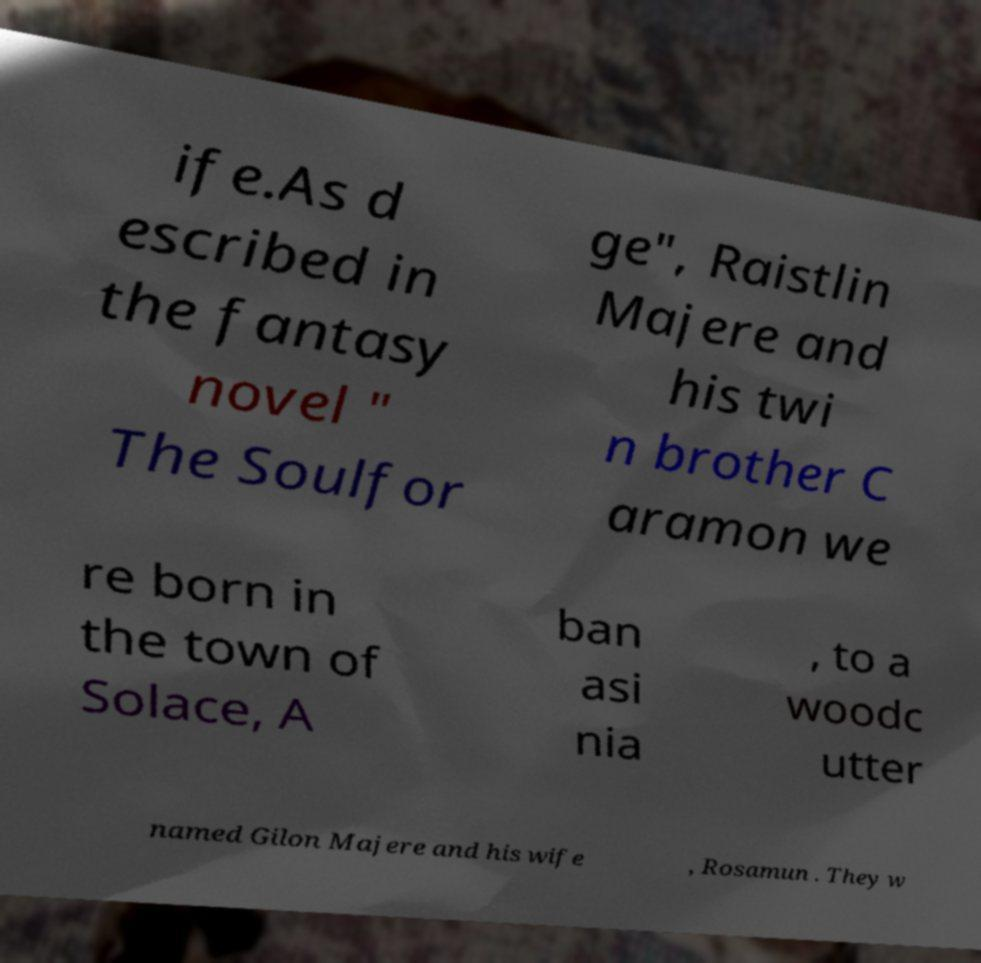There's text embedded in this image that I need extracted. Can you transcribe it verbatim? ife.As d escribed in the fantasy novel " The Soulfor ge", Raistlin Majere and his twi n brother C aramon we re born in the town of Solace, A ban asi nia , to a woodc utter named Gilon Majere and his wife , Rosamun . They w 